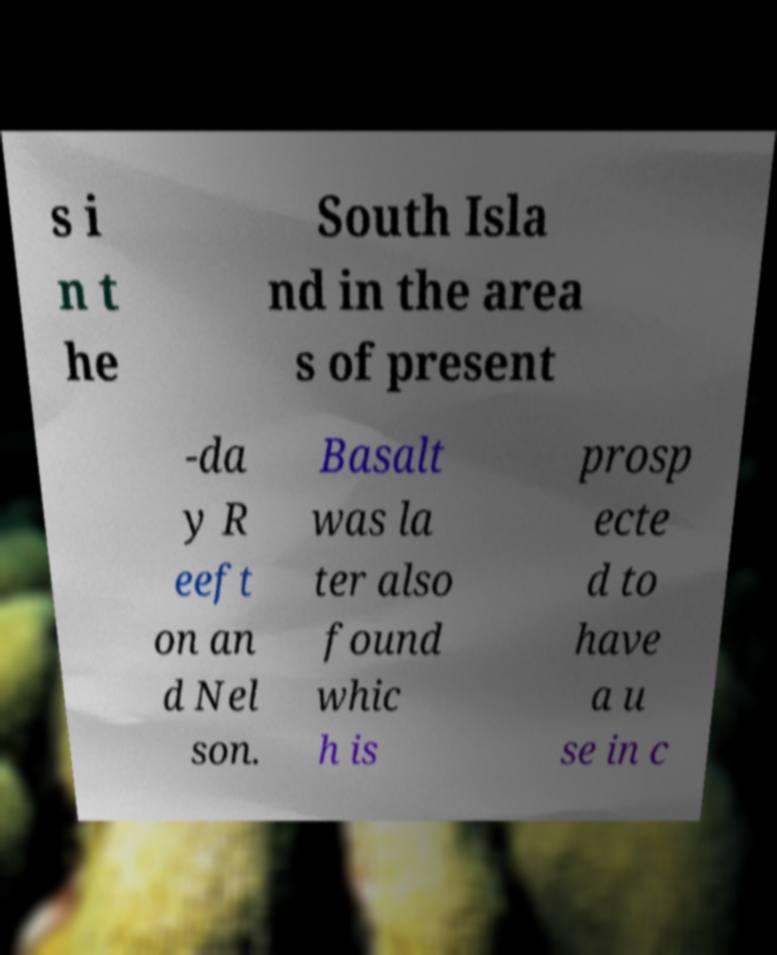I need the written content from this picture converted into text. Can you do that? s i n t he South Isla nd in the area s of present -da y R eeft on an d Nel son. Basalt was la ter also found whic h is prosp ecte d to have a u se in c 